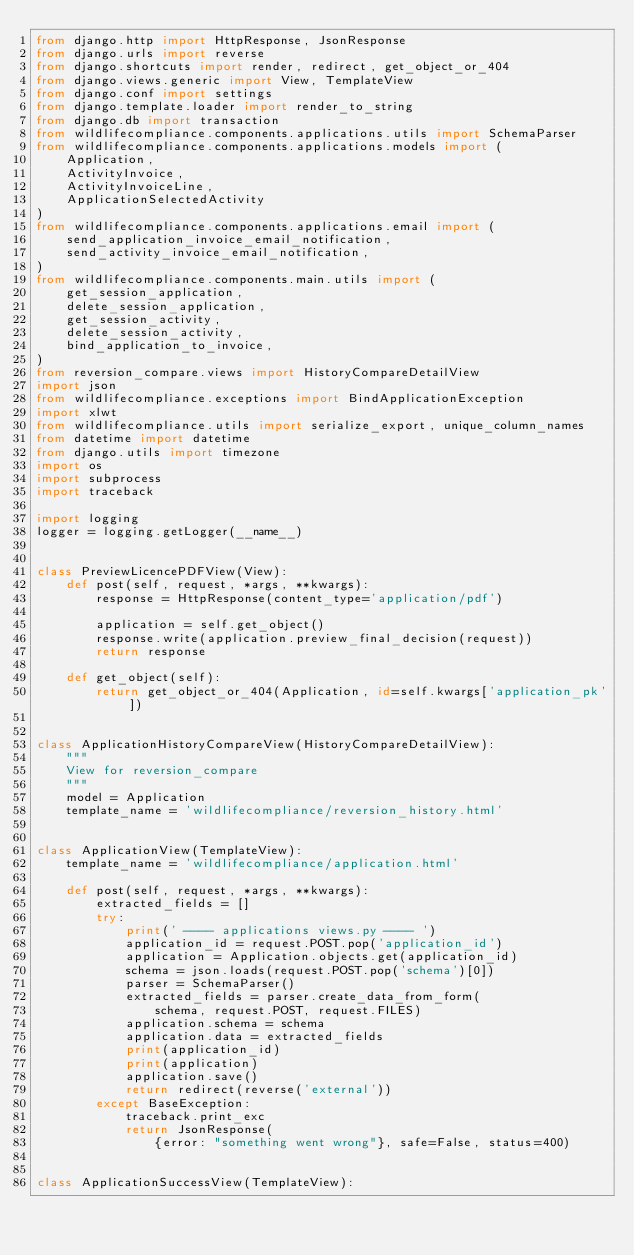<code> <loc_0><loc_0><loc_500><loc_500><_Python_>from django.http import HttpResponse, JsonResponse
from django.urls import reverse
from django.shortcuts import render, redirect, get_object_or_404
from django.views.generic import View, TemplateView
from django.conf import settings
from django.template.loader import render_to_string
from django.db import transaction
from wildlifecompliance.components.applications.utils import SchemaParser
from wildlifecompliance.components.applications.models import (
    Application,
    ActivityInvoice,
    ActivityInvoiceLine,
    ApplicationSelectedActivity
)
from wildlifecompliance.components.applications.email import (
    send_application_invoice_email_notification,
    send_activity_invoice_email_notification,
)
from wildlifecompliance.components.main.utils import (
    get_session_application,
    delete_session_application,
    get_session_activity,
    delete_session_activity,
    bind_application_to_invoice,
)
from reversion_compare.views import HistoryCompareDetailView
import json
from wildlifecompliance.exceptions import BindApplicationException
import xlwt
from wildlifecompliance.utils import serialize_export, unique_column_names
from datetime import datetime
from django.utils import timezone
import os
import subprocess
import traceback

import logging
logger = logging.getLogger(__name__)


class PreviewLicencePDFView(View):
    def post(self, request, *args, **kwargs):
        response = HttpResponse(content_type='application/pdf')

        application = self.get_object()
        response.write(application.preview_final_decision(request))
        return response

    def get_object(self):
        return get_object_or_404(Application, id=self.kwargs['application_pk'])


class ApplicationHistoryCompareView(HistoryCompareDetailView):
    """
    View for reversion_compare
    """
    model = Application
    template_name = 'wildlifecompliance/reversion_history.html'


class ApplicationView(TemplateView):
    template_name = 'wildlifecompliance/application.html'

    def post(self, request, *args, **kwargs):
        extracted_fields = []
        try:
            print(' ---- applications views.py ---- ')
            application_id = request.POST.pop('application_id')
            application = Application.objects.get(application_id)
            schema = json.loads(request.POST.pop('schema')[0])
            parser = SchemaParser()
            extracted_fields = parser.create_data_from_form(
                schema, request.POST, request.FILES)
            application.schema = schema
            application.data = extracted_fields
            print(application_id)
            print(application)
            application.save()
            return redirect(reverse('external'))
        except BaseException:
            traceback.print_exc
            return JsonResponse(
                {error: "something went wrong"}, safe=False, status=400)


class ApplicationSuccessView(TemplateView):</code> 